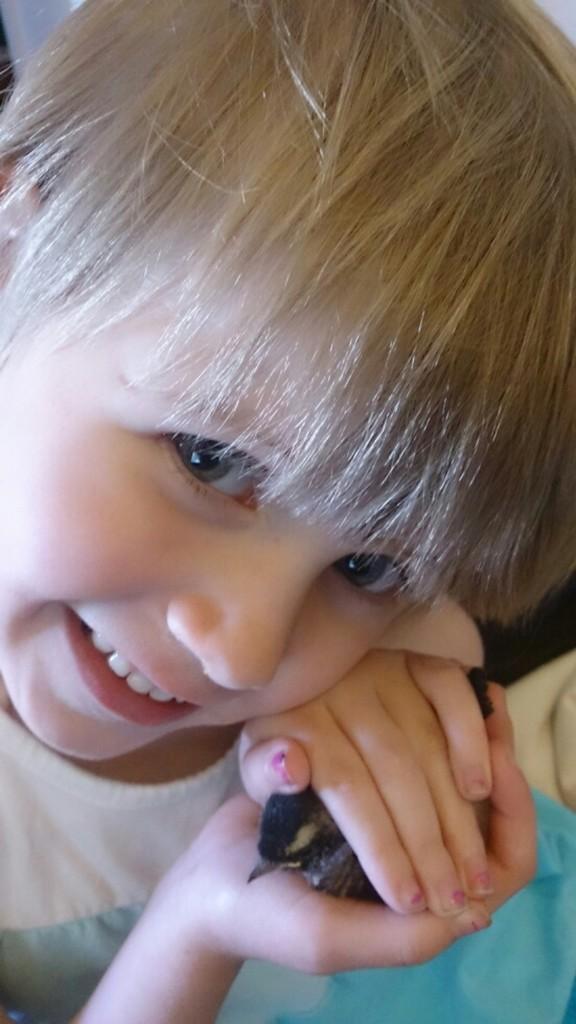Please provide a concise description of this image. There is a child smiling and holding an object with both hands. In the background, there is an object. 